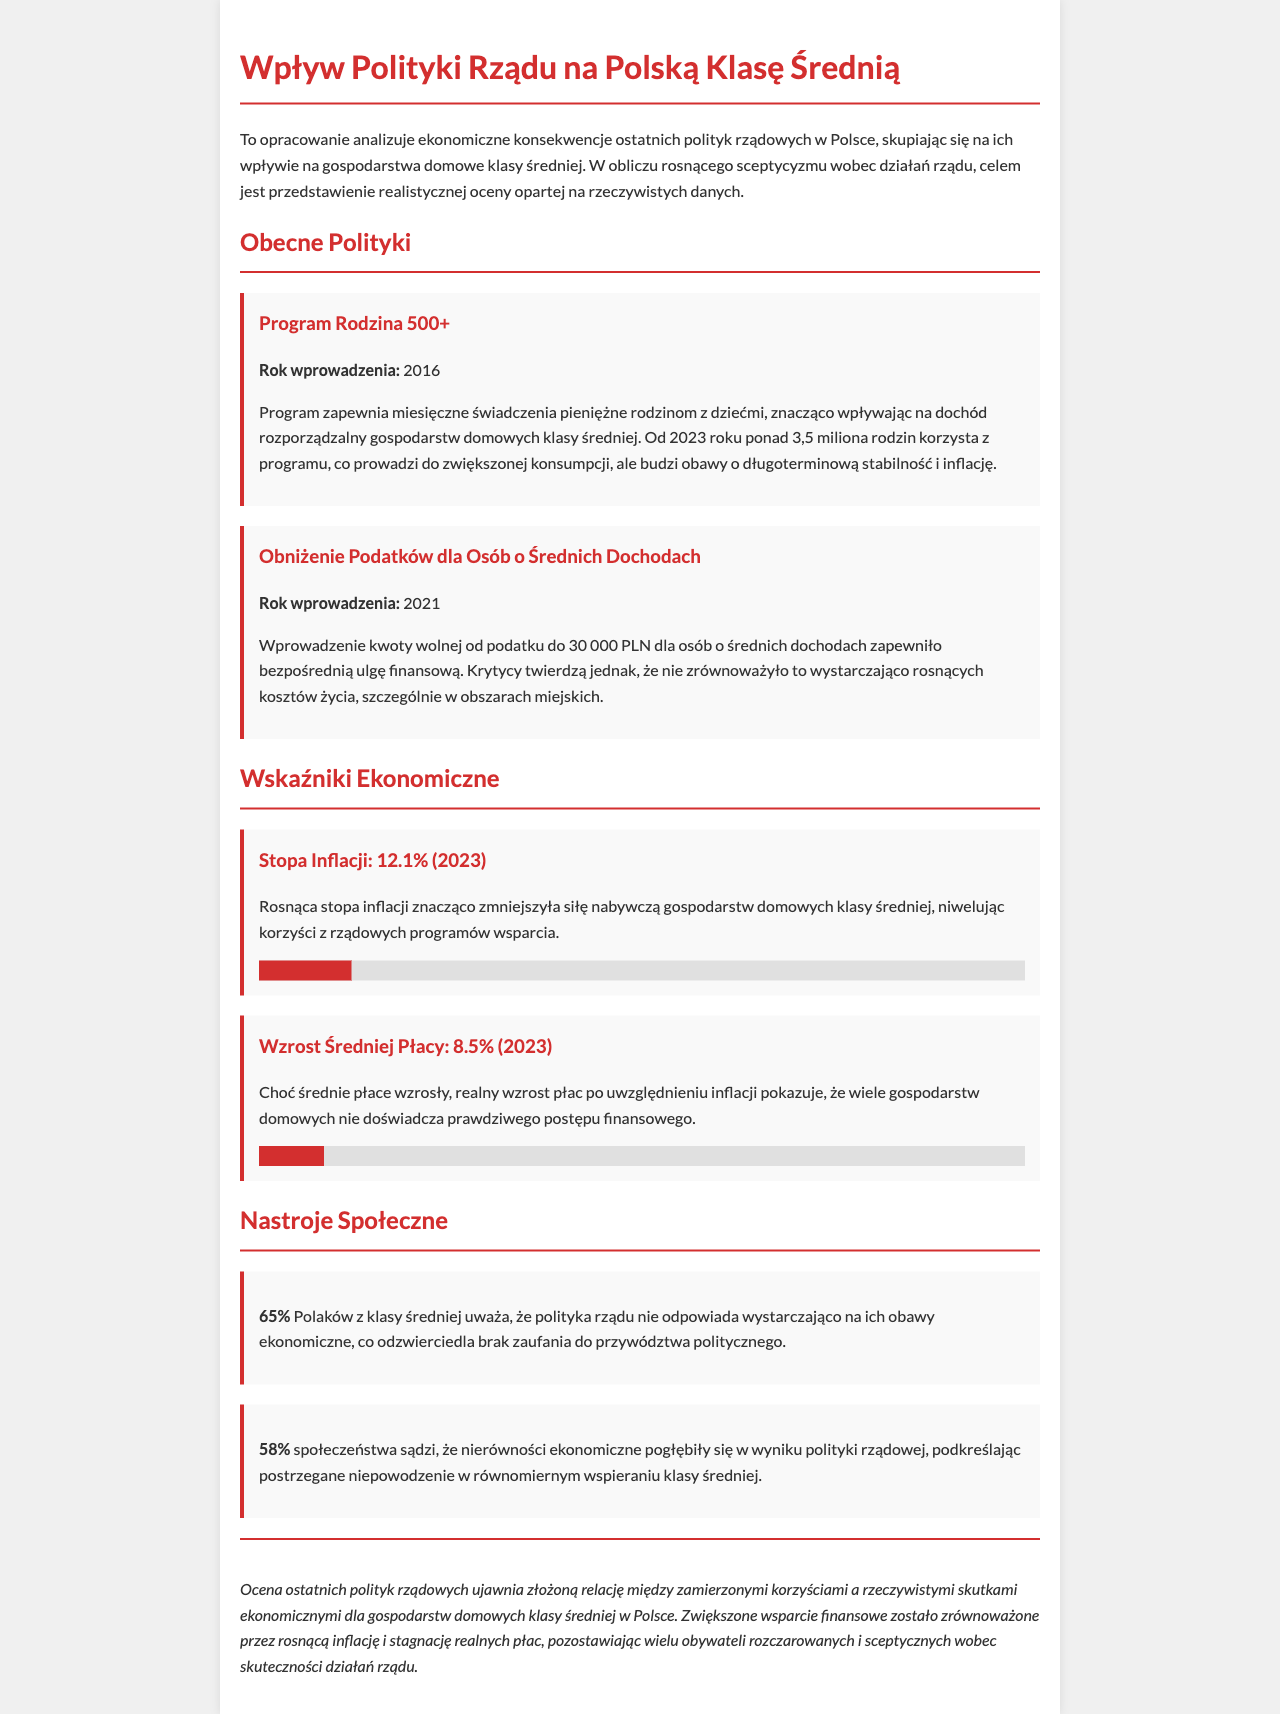what is the introduced year of the Family 500+ program? The document states that the Family 500+ program was introduced in 2016.
Answer: 2016 what percentage of Poles from the middle class believe that government policy does not adequately address their economic concerns? The report mentions that 65% of Poles from the middle class feel that the government policy does not meet their economic concerns.
Answer: 65% what is the inflation rate reported for 2023? According to the document, the inflation rate for 2023 is 12.1%.
Answer: 12.1% what is the declared income tax-free amount under the tax reduction policy? The policy indicates that the income tax-free amount was set to 30,000 PLN for individuals with middle incomes.
Answer: 30,000 PLN how much has the average wage increased in 2023? The report notes that the average wage has increased by 8.5% in 2023.
Answer: 8.5% what percentage of society believes that economic inequalities have deepened as a result of government policy? The document states that 58% of society believes that economic inequalities have worsened due to government policy.
Answer: 58% what was the main disadvantage reported concerning the tax reduction for middle-income individuals? Critics argue that the tax reduction did not sufficiently balance the rising cost of living, especially in urban areas.
Answer: rising cost of living what is the primary conclusion drawn about recent government policies affecting the middle class? The conclusion states that there is a complex relationship between intended benefits and actual economic outcomes for middle-class households.
Answer: complex relationship 